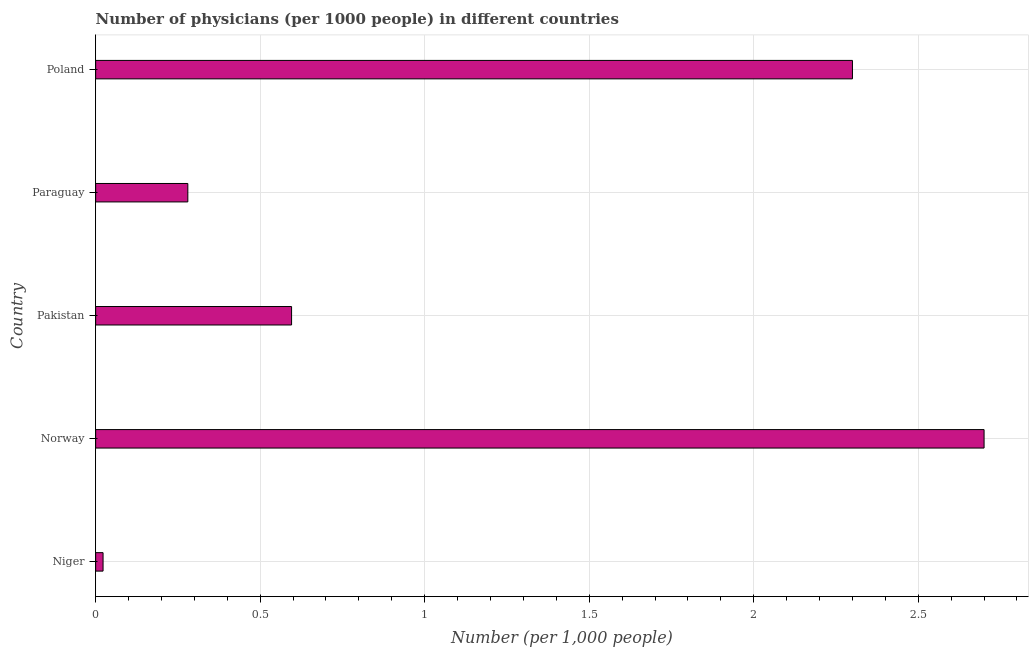Does the graph contain grids?
Your answer should be compact. Yes. What is the title of the graph?
Offer a terse response. Number of physicians (per 1000 people) in different countries. What is the label or title of the X-axis?
Keep it short and to the point. Number (per 1,0 people). What is the number of physicians in Niger?
Provide a short and direct response. 0.02. Across all countries, what is the minimum number of physicians?
Offer a terse response. 0.02. In which country was the number of physicians maximum?
Your response must be concise. Norway. In which country was the number of physicians minimum?
Offer a terse response. Niger. What is the sum of the number of physicians?
Provide a succinct answer. 5.9. What is the difference between the number of physicians in Pakistan and Paraguay?
Your answer should be compact. 0.32. What is the average number of physicians per country?
Your answer should be very brief. 1.18. What is the median number of physicians?
Keep it short and to the point. 0.6. In how many countries, is the number of physicians greater than 2.2 ?
Keep it short and to the point. 2. What is the ratio of the number of physicians in Paraguay to that in Poland?
Make the answer very short. 0.12. Is the number of physicians in Norway less than that in Paraguay?
Offer a very short reply. No. Is the difference between the number of physicians in Paraguay and Poland greater than the difference between any two countries?
Your answer should be compact. No. What is the difference between the highest and the second highest number of physicians?
Offer a terse response. 0.4. What is the difference between the highest and the lowest number of physicians?
Offer a very short reply. 2.68. In how many countries, is the number of physicians greater than the average number of physicians taken over all countries?
Your answer should be compact. 2. Are all the bars in the graph horizontal?
Offer a very short reply. Yes. Are the values on the major ticks of X-axis written in scientific E-notation?
Ensure brevity in your answer.  No. What is the Number (per 1,000 people) of Niger?
Your response must be concise. 0.02. What is the Number (per 1,000 people) of Pakistan?
Offer a terse response. 0.6. What is the Number (per 1,000 people) of Paraguay?
Provide a short and direct response. 0.28. What is the difference between the Number (per 1,000 people) in Niger and Norway?
Provide a short and direct response. -2.68. What is the difference between the Number (per 1,000 people) in Niger and Pakistan?
Your response must be concise. -0.57. What is the difference between the Number (per 1,000 people) in Niger and Paraguay?
Your response must be concise. -0.26. What is the difference between the Number (per 1,000 people) in Niger and Poland?
Offer a terse response. -2.28. What is the difference between the Number (per 1,000 people) in Norway and Pakistan?
Offer a terse response. 2.1. What is the difference between the Number (per 1,000 people) in Norway and Paraguay?
Provide a succinct answer. 2.42. What is the difference between the Number (per 1,000 people) in Pakistan and Paraguay?
Make the answer very short. 0.32. What is the difference between the Number (per 1,000 people) in Pakistan and Poland?
Provide a succinct answer. -1.7. What is the difference between the Number (per 1,000 people) in Paraguay and Poland?
Provide a succinct answer. -2.02. What is the ratio of the Number (per 1,000 people) in Niger to that in Norway?
Your response must be concise. 0.01. What is the ratio of the Number (per 1,000 people) in Niger to that in Pakistan?
Offer a very short reply. 0.04. What is the ratio of the Number (per 1,000 people) in Niger to that in Paraguay?
Your answer should be compact. 0.08. What is the ratio of the Number (per 1,000 people) in Norway to that in Pakistan?
Give a very brief answer. 4.54. What is the ratio of the Number (per 1,000 people) in Norway to that in Paraguay?
Offer a terse response. 9.64. What is the ratio of the Number (per 1,000 people) in Norway to that in Poland?
Provide a succinct answer. 1.17. What is the ratio of the Number (per 1,000 people) in Pakistan to that in Paraguay?
Your answer should be very brief. 2.13. What is the ratio of the Number (per 1,000 people) in Pakistan to that in Poland?
Your response must be concise. 0.26. What is the ratio of the Number (per 1,000 people) in Paraguay to that in Poland?
Your answer should be compact. 0.12. 